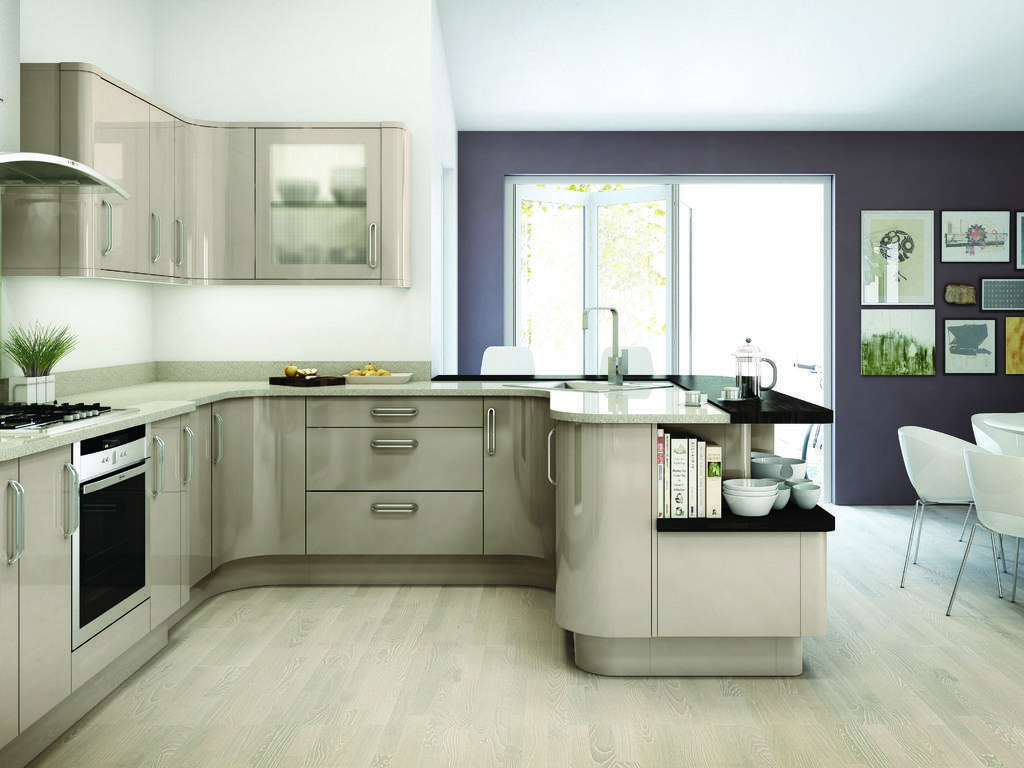In one or two sentences, can you explain what this image depicts? This is an inner view of a room in which we can see a stove, a plant in a pot and some fruits in the plates which are placed on the counter top. We can also see the cupboards, a sink with a tap, some books and bowls placed on the surface, a window and some frames on a wall. On the right side we can see some chairs placed on the floor. 